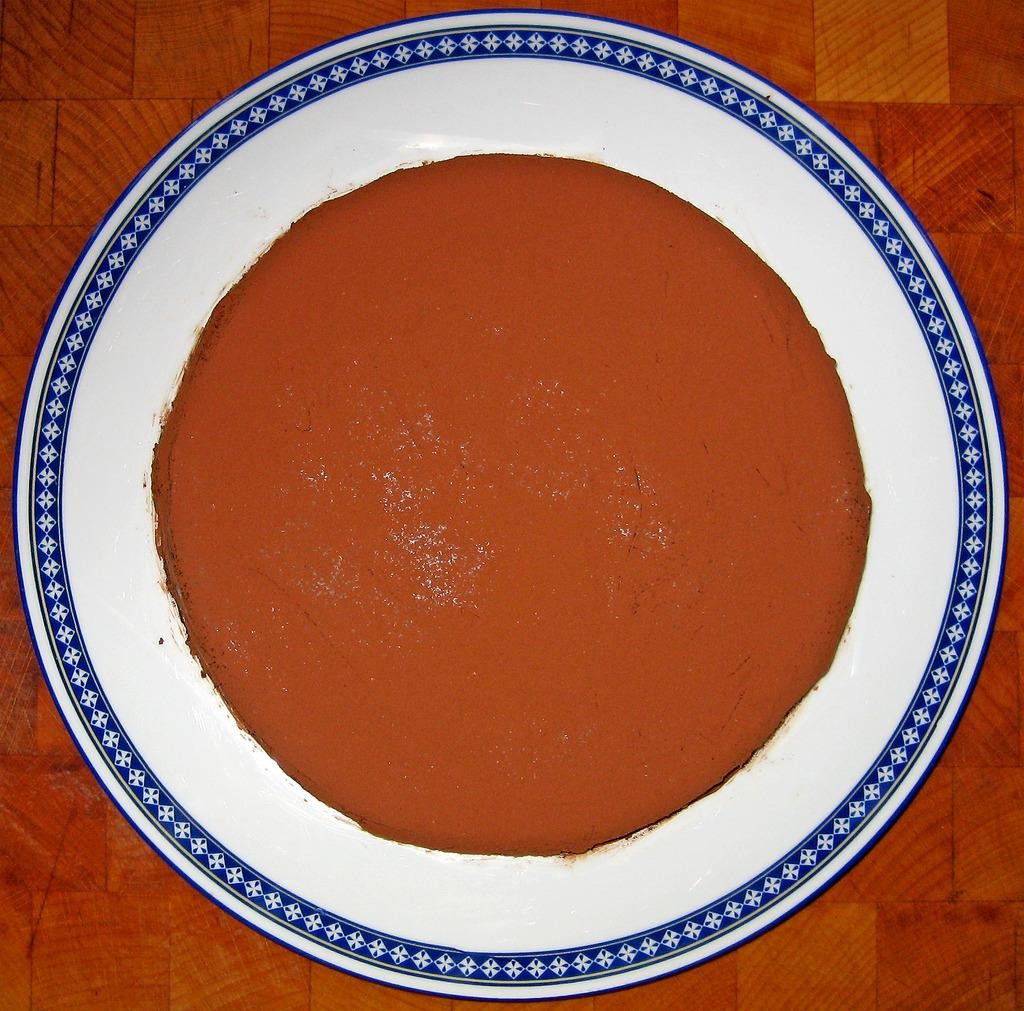What type of food item is visible in the image? The food item is brown in color. What color is the plate on which the food item is placed? The plate is white in color. What color is the surface on which the plate is placed? The surface is brown in color. What type of card is visible in the image? There is no card present in the image. Is there a crib in the image? There is no crib present in the image. 